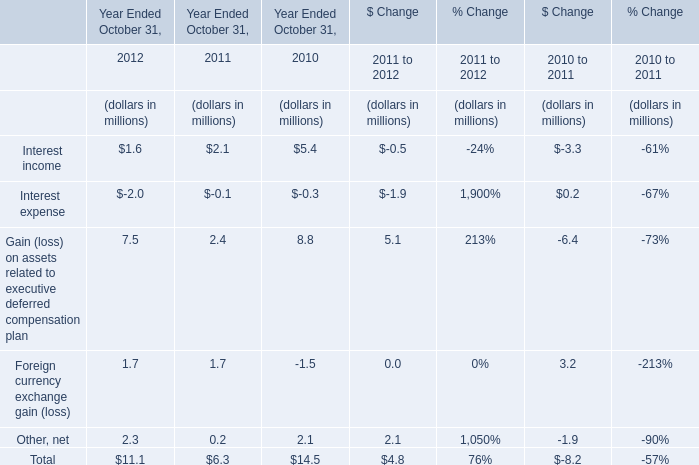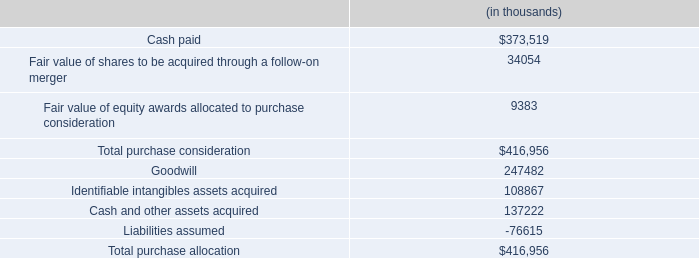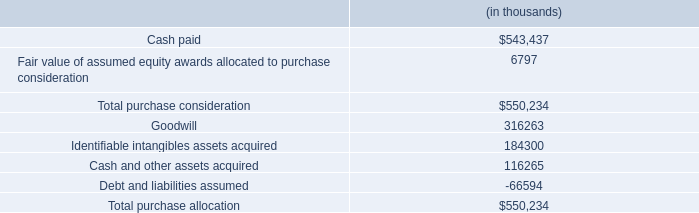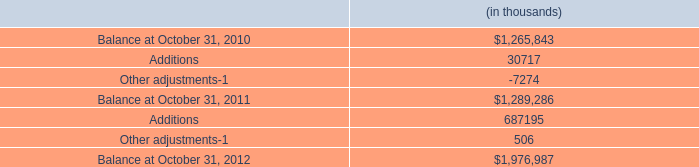What do all Year Ended October 31, sum up in 2012 , excluding Interest income and Interest expense? (in million) 
Computations: ((7.5 + 1.7) + 2.3)
Answer: 11.5. 